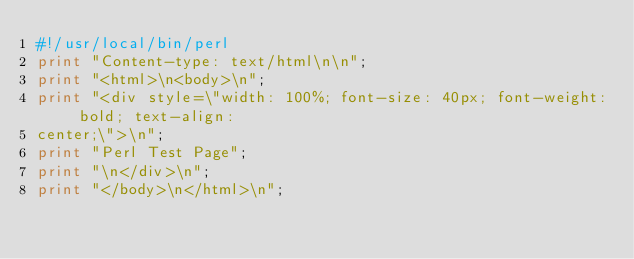<code> <loc_0><loc_0><loc_500><loc_500><_Perl_>#!/usr/local/bin/perl
print "Content-type: text/html\n\n";
print "<html>\n<body>\n";
print "<div style=\"width: 100%; font-size: 40px; font-weight: bold; text-align: 
center;\">\n";
print "Perl Test Page";
print "\n</div>\n";
print "</body>\n</html>\n";

</code> 